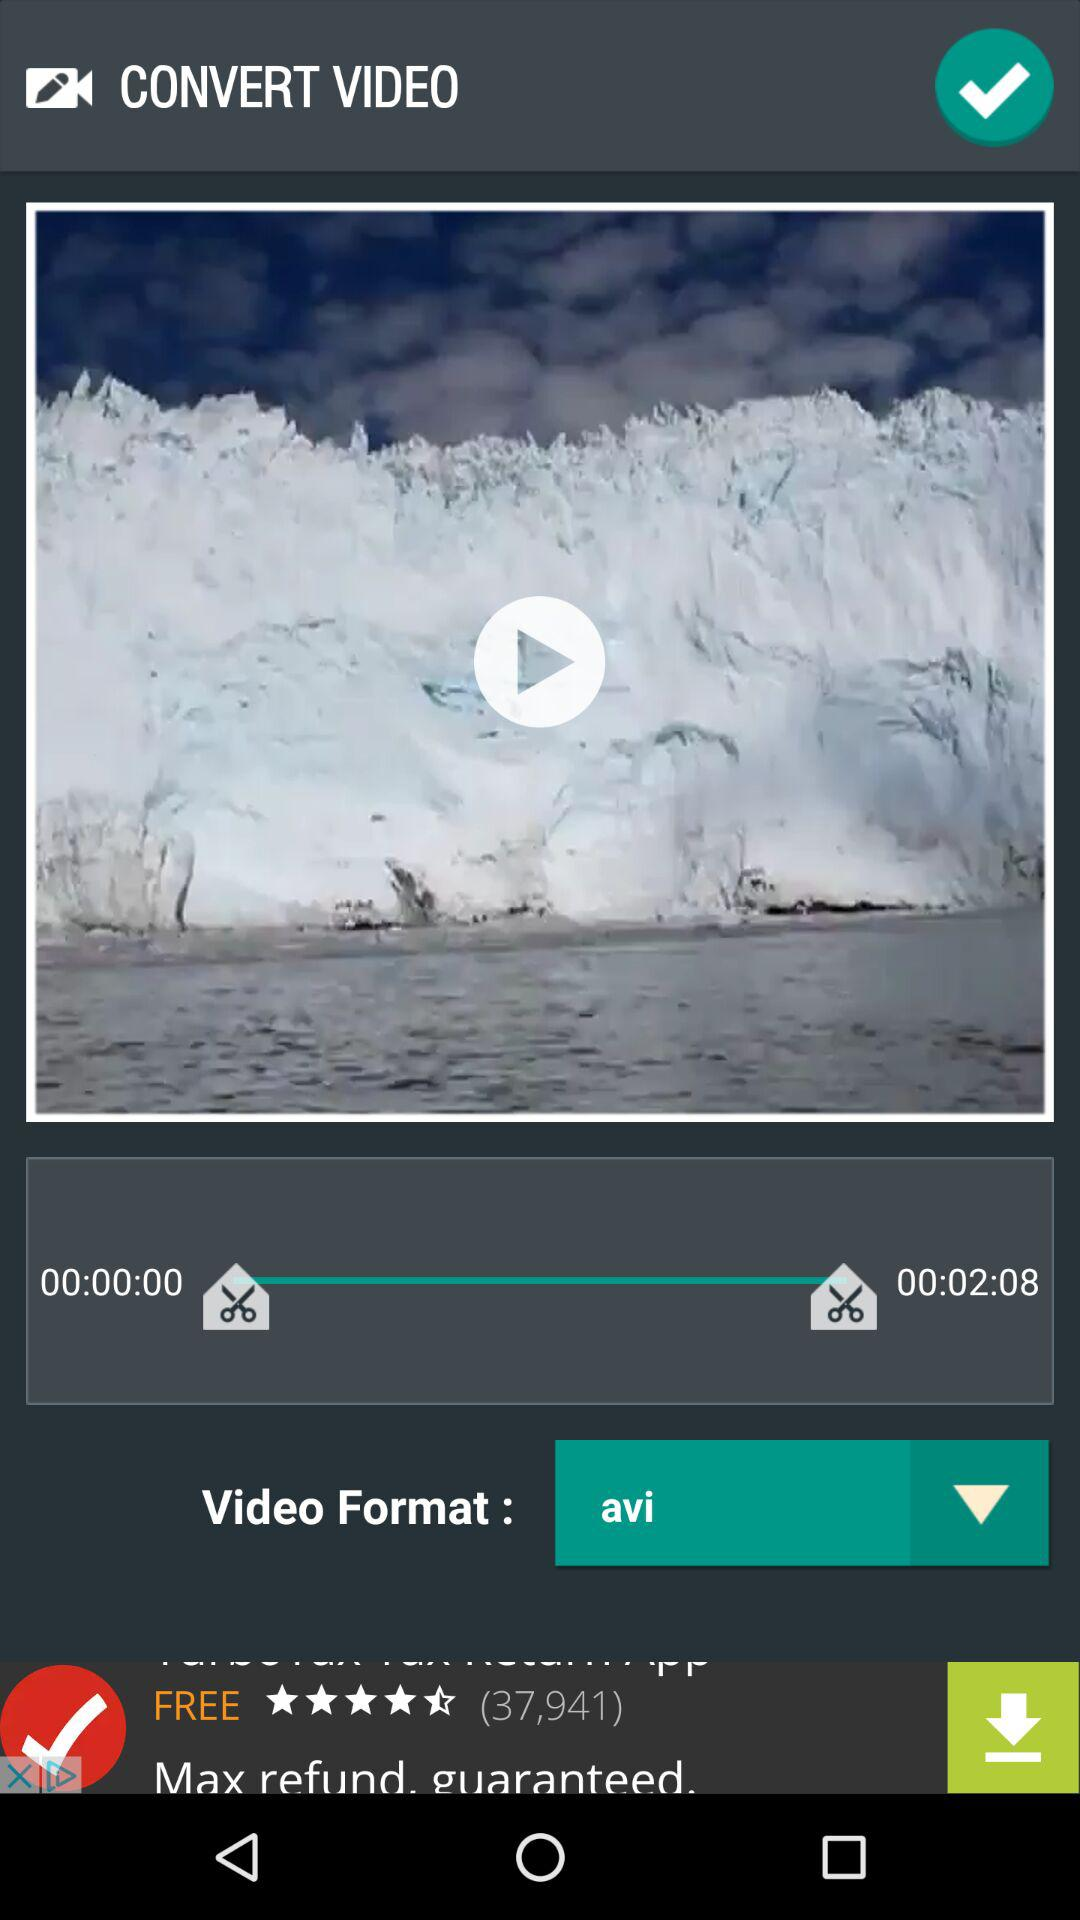How long is the video? The video is 2 minutes 8 seconds long. 